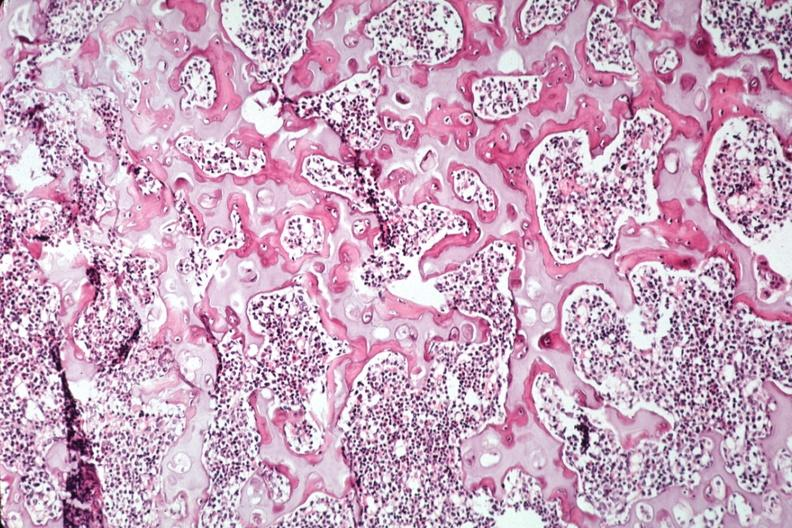what does this image show?
Answer the question using a single word or phrase. Nice photo of ossifying trabecular bone 